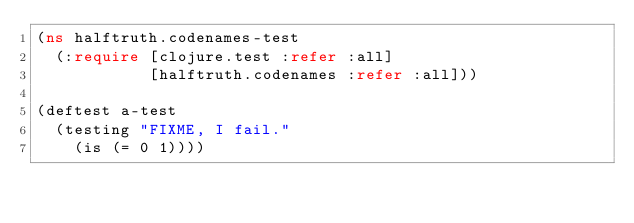<code> <loc_0><loc_0><loc_500><loc_500><_Clojure_>(ns halftruth.codenames-test
  (:require [clojure.test :refer :all]
            [halftruth.codenames :refer :all]))

(deftest a-test
  (testing "FIXME, I fail."
    (is (= 0 1))))
</code> 